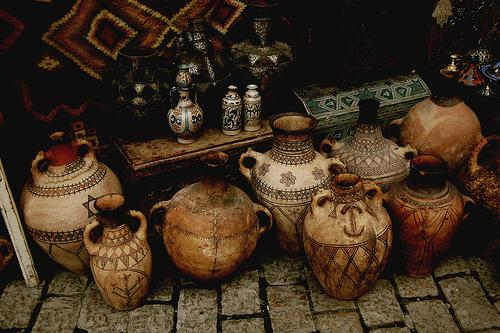Question: what is in this picture?
Choices:
A. Bowls.
B. Buckets.
C. Pots.
D. Vases.
Answer with the letter. Answer: C Question: who took this picture?
Choices:
A. Boss.
B. Stranger.
C. Customer.
D. Friend.
Answer with the letter. Answer: C Question: what is in the background?
Choices:
A. Wall.
B. Blanket.
C. Tent.
D. Curtain.
Answer with the letter. Answer: B Question: what color are the pots?
Choices:
A. Red.
B. Clay.
C. Black.
D. White.
Answer with the letter. Answer: B 